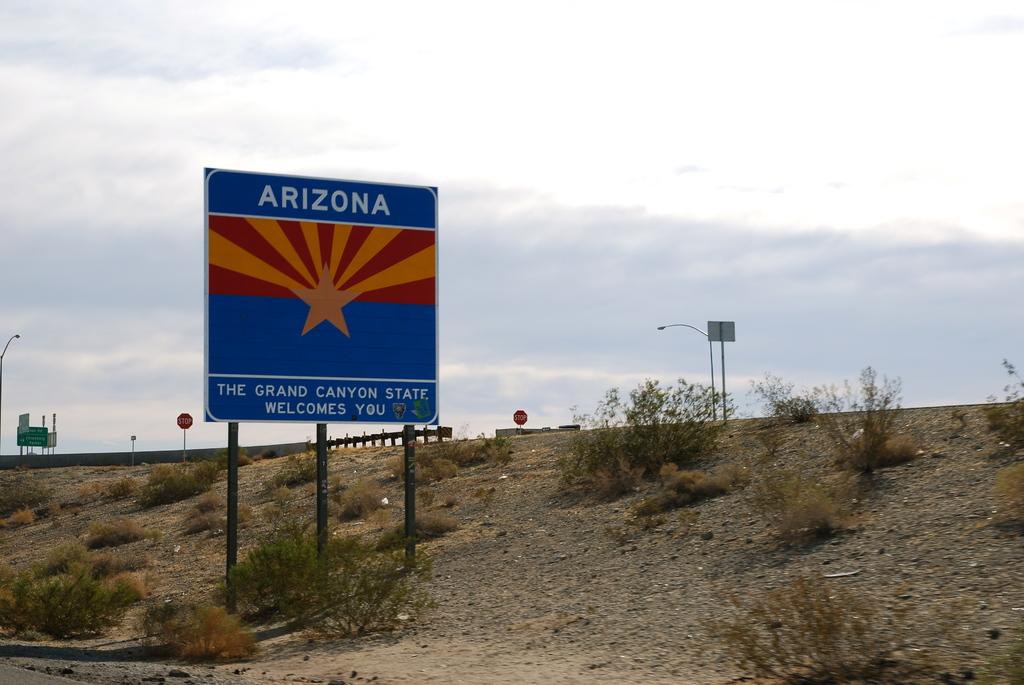What state is this sign in?
Your answer should be compact. Arizona. What landmark is mentioned on the sign?
Give a very brief answer. Grand canyon. 